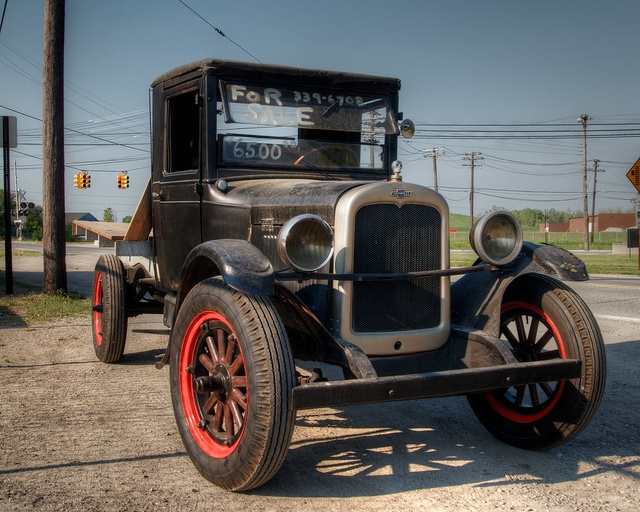Describe the objects in this image and their specific colors. I can see truck in gray, black, and maroon tones, traffic light in gray, tan, darkgray, red, and black tones, traffic light in gray, brown, maroon, orange, and tan tones, traffic light in gray, khaki, darkgray, orange, and tan tones, and traffic light in gray, olive, darkgray, black, and tan tones in this image. 